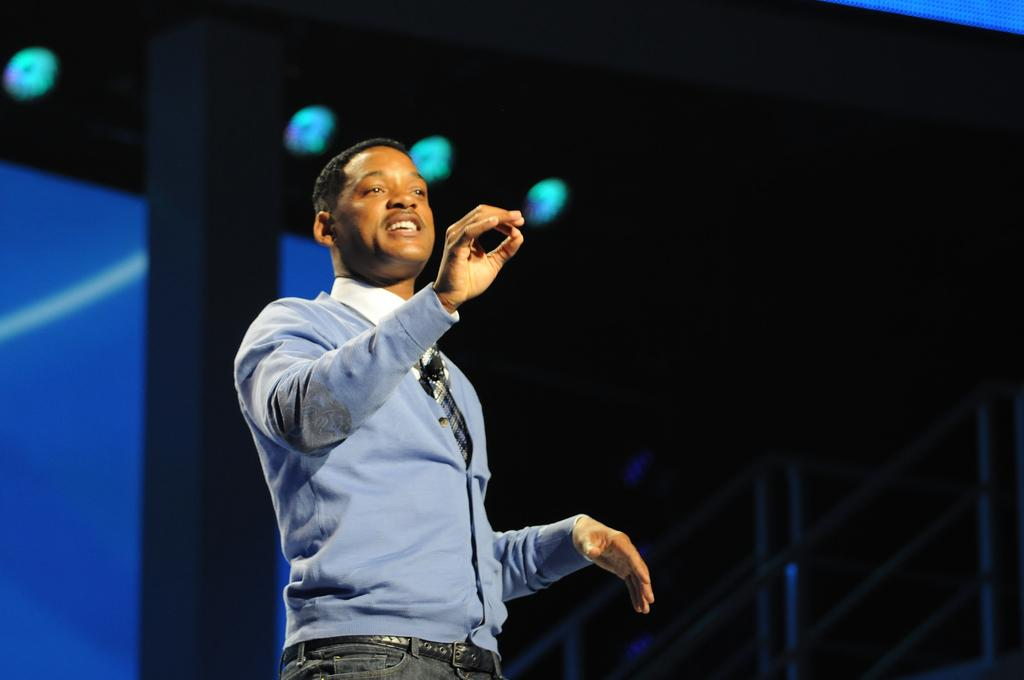What is the man in the image doing? The man is standing and talking in the image. How would you describe the lighting in the image? The background of the image is dark. What architectural features can be seen in the background of the image? There is railing and a pillar visible in the background of the image. What else can be seen in the background of the image? There are lights in the background of the image. What type of thread is being used in the battle scene depicted in the image? There is no battle scene or thread present in the image; it features a man standing and talking with a dark background and architectural features. 